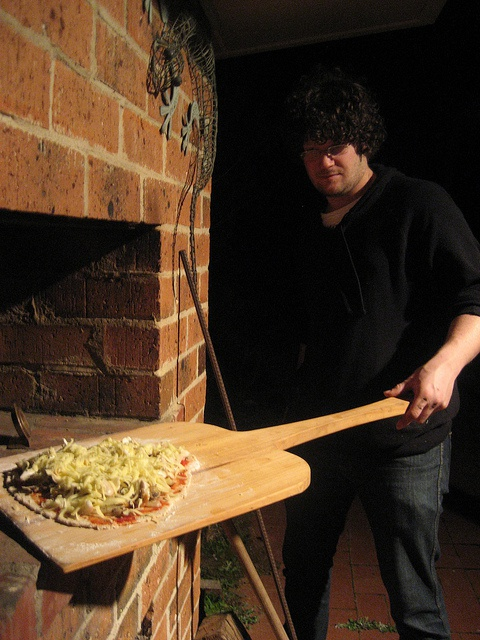Describe the objects in this image and their specific colors. I can see people in brown, black, maroon, and tan tones and pizza in brown, tan, khaki, and olive tones in this image. 